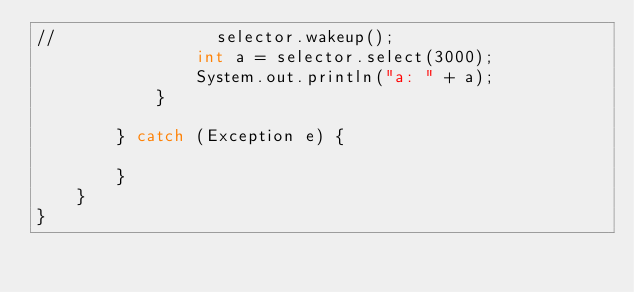Convert code to text. <code><loc_0><loc_0><loc_500><loc_500><_Java_>//                selector.wakeup();
                int a = selector.select(3000);
                System.out.println("a: " + a);
            }

        } catch (Exception e) {

        }
    }
}
</code> 